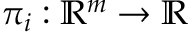Convert formula to latex. <formula><loc_0><loc_0><loc_500><loc_500>\pi _ { i } \colon \mathbb { R } ^ { m } \to \mathbb { R }</formula> 